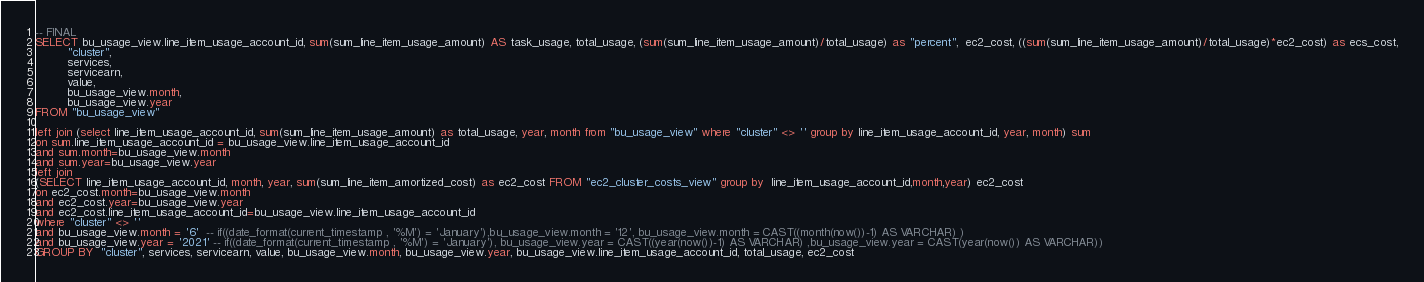<code> <loc_0><loc_0><loc_500><loc_500><_SQL_>-- FINAL
SELECT bu_usage_view.line_item_usage_account_id, sum(sum_line_item_usage_amount) AS task_usage, total_usage, (sum(sum_line_item_usage_amount)/total_usage) as "percent",  ec2_cost, ((sum(sum_line_item_usage_amount)/total_usage)*ec2_cost) as ecs_cost,
         "cluster",
         services,
         servicearn,
         value,
         bu_usage_view.month,
         bu_usage_view.year
FROM "bu_usage_view"

left join (select line_item_usage_account_id, sum(sum_line_item_usage_amount) as total_usage, year, month from "bu_usage_view" where "cluster" <> '' group by line_item_usage_account_id, year, month) sum
on sum.line_item_usage_account_id = bu_usage_view.line_item_usage_account_id
and sum.month=bu_usage_view.month
and sum.year=bu_usage_view.year
left join
(SELECT line_item_usage_account_id, month, year, sum(sum_line_item_amortized_cost) as ec2_cost FROM "ec2_cluster_costs_view" group by  line_item_usage_account_id,month,year) ec2_cost
on ec2_cost.month=bu_usage_view.month
and ec2_cost.year=bu_usage_view.year
and ec2_cost.line_item_usage_account_id=bu_usage_view.line_item_usage_account_id
where "cluster" <> '' 
and bu_usage_view.month = '6'  -- if((date_format(current_timestamp , '%M') = 'January'),bu_usage_view.month = '12', bu_usage_view.month = CAST((month(now())-1) AS VARCHAR) )
and bu_usage_view.year = '2021' -- if((date_format(current_timestamp , '%M') = 'January'), bu_usage_view.year = CAST((year(now())-1) AS VARCHAR) ,bu_usage_view.year = CAST(year(now()) AS VARCHAR))
GROUP BY  "cluster", services, servicearn, value, bu_usage_view.month, bu_usage_view.year, bu_usage_view.line_item_usage_account_id, total_usage, ec2_cost</code> 